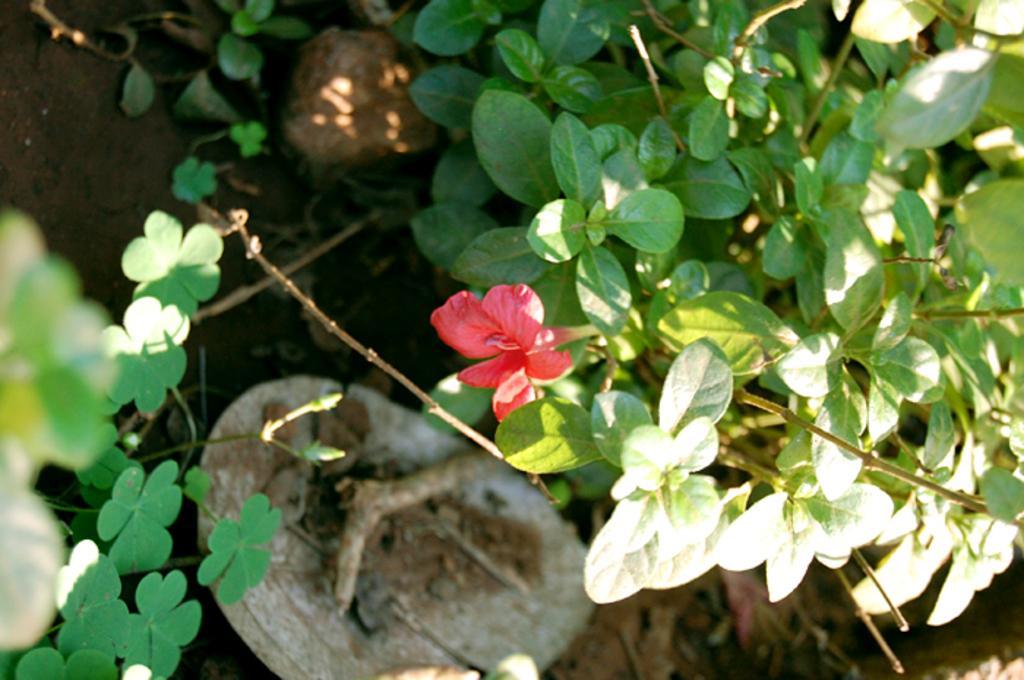Could you give a brief overview of what you see in this image? In the image there is plant and a flower on it. The flower is of pink colour. There are two rocks and the soil is at the bottom. 